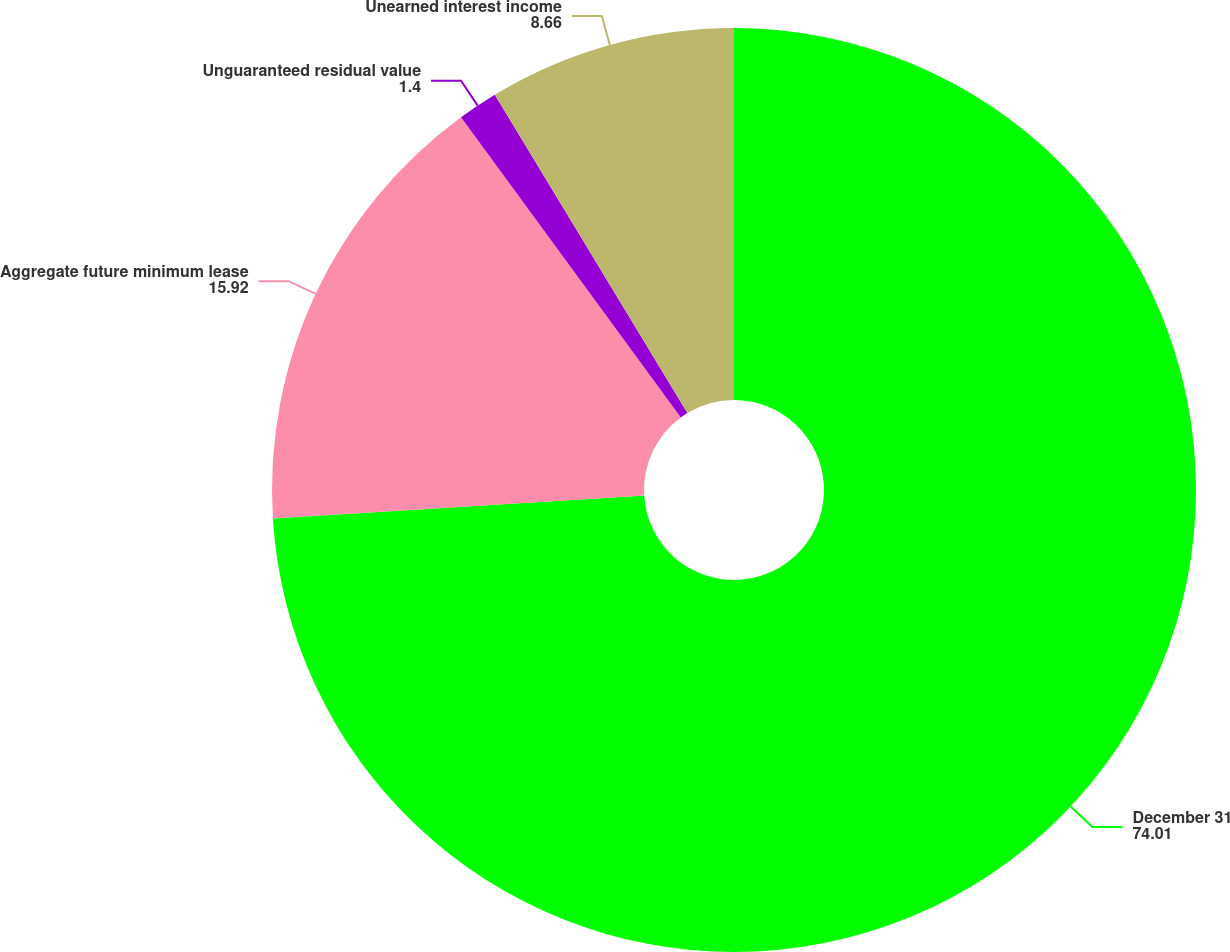Convert chart to OTSL. <chart><loc_0><loc_0><loc_500><loc_500><pie_chart><fcel>December 31<fcel>Aggregate future minimum lease<fcel>Unguaranteed residual value<fcel>Unearned interest income<nl><fcel>74.01%<fcel>15.92%<fcel>1.4%<fcel>8.66%<nl></chart> 